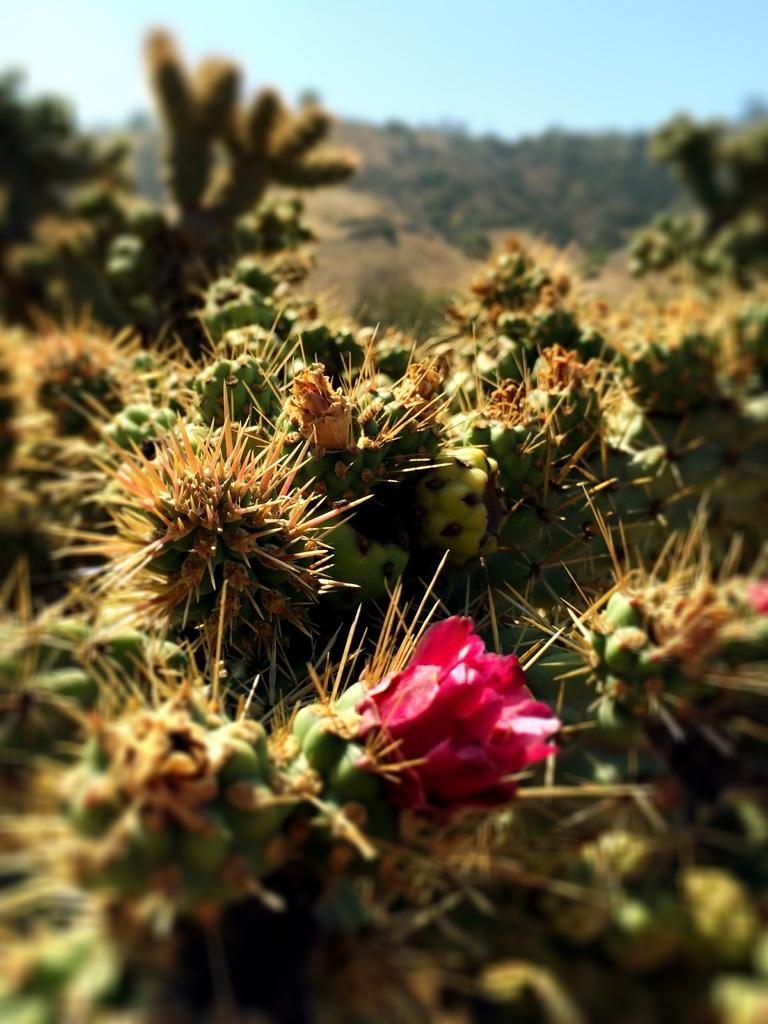What type of plants are present in the image? There are cactus plants with thorns in the image. Are there any flowers visible in the image? Yes, there is a red flower in the image. How would you describe the background of the image? The background appears blurry. What might be the cause of the blurry background? The blurry background might be the sky. Can you see any feathers on the cactus plants in the image? No, there are no feathers present on the cactus plants in the image. What type of wax might be used to create the red flower in the image? The image does not provide any information about the creation of the red flower, so it is not possible to determine what type of wax might have been used. 